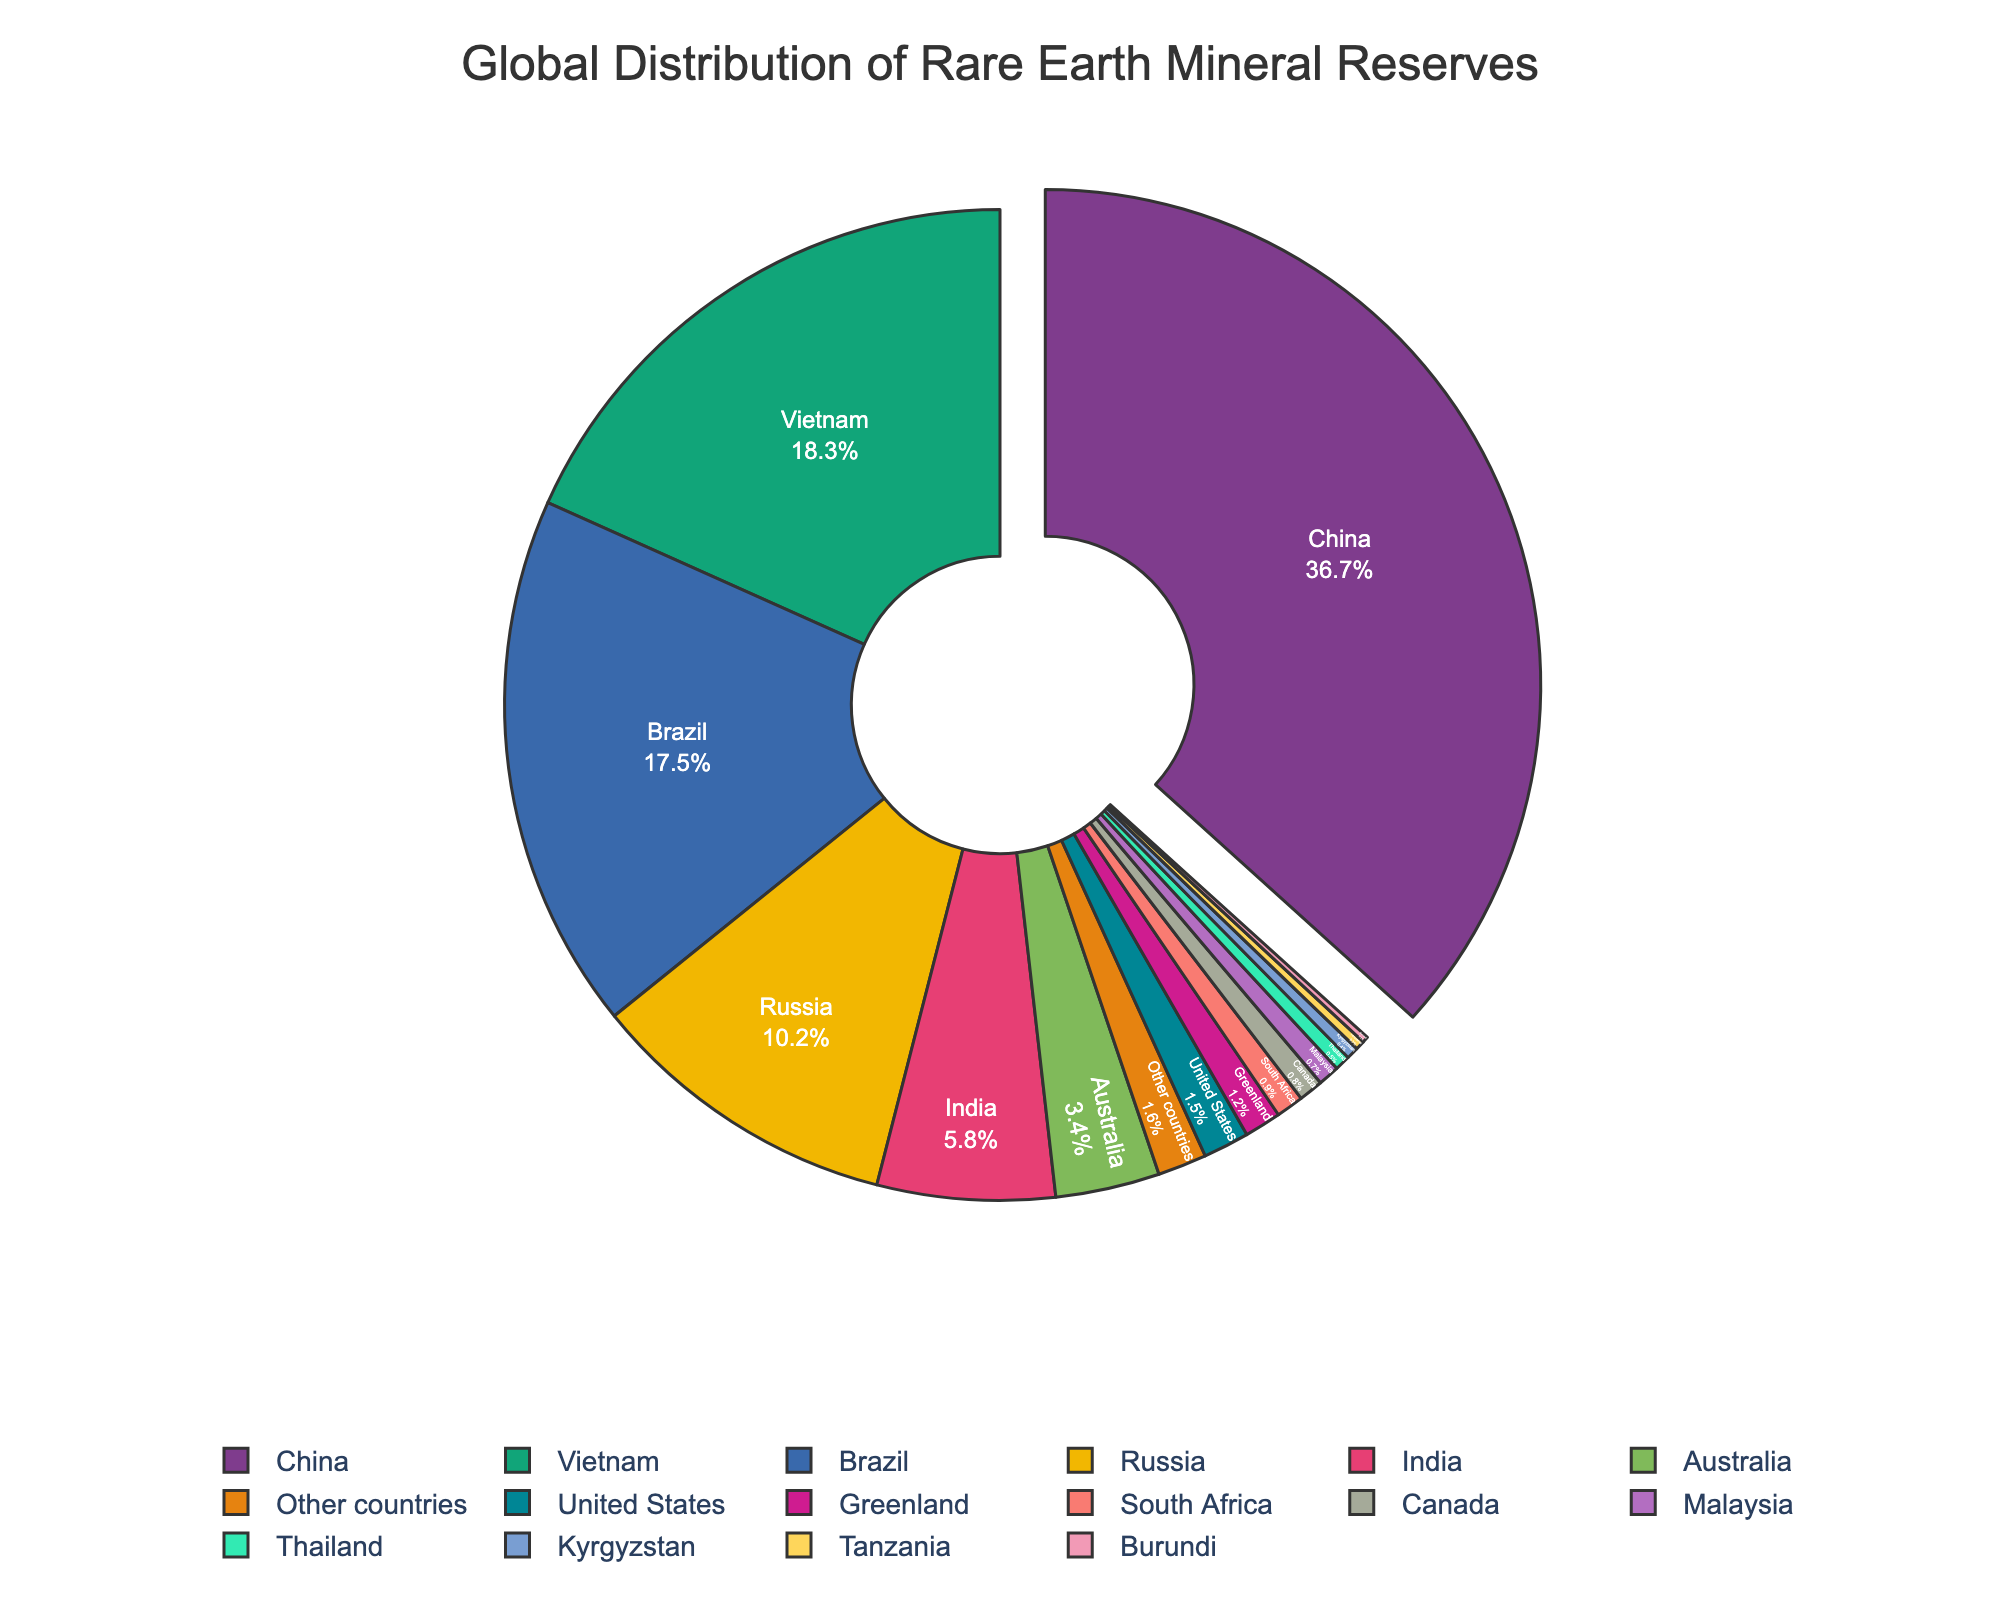What's the percentage contribution of China and Vietnam combined? China contributes 36.7% and Vietnam contributes 18.3%. Adding these together, 36.7 + 18.3 = 55.
Answer: 55% Which country has a higher percentage of reserves, Brazil or Russia? Brazil contributes 17.5% and Russia contributes 10.2%. Since 17.5 is greater than 10.2, Brazil has a higher percentage.
Answer: Brazil What is the combined percentage contribution of the United States, Greenland, and Canada? The United States contributes 1.5%, Greenland contributes 1.2%, and Canada contributes 0.8%. Adding these together, 1.5 + 1.2 + 0.8 = 3.5
Answer: 3.5% Excluding China, which country has the largest share of rare earth mineral reserves? Excluding China, the largest share is held by Vietnam, which has 18.3%.
Answer: Vietnam If we sum the contributions of India, Australia, and South Africa, how does it compare to Russia's contribution? India contributes 5.8%, Australia contributes 3.4%, and South Africa contributes 0.9%. Summing these, 5.8 + 3.4 + 0.9 = 10.1%, which is less than Russia's 10.2%.
Answer: Less than Russia What percentage of the global reserves is held by countries other than China, Vietnam, and Brazil? China holds 36.7%, Vietnam holds 18.3%, and Brazil holds 17.5%. Summing these gives 36.7 + 18.3 + 17.5 = 72.5%. The remaining percentage is 100 - 72.5 = 27.5%.
Answer: 27.5% Between India and Australia, which country has a lower percentage of reserves? India contributes 5.8% and Australia contributes 3.4%. Since 3.4 is less than 5.8, Australia has a lower percentage.
Answer: Australia Which three countries together encompass roughly a third of the global reserves? A third of the global reserves is approximately 33.3%. China contributes 36.7%, which alone is more than 33.3%. Excluding China, the next largest contributors are Vietnam (18.3%) and Brazil (17.5%), whose combined contribution, 18.3 + 17.5 = 35.8%, is also over a third. However, no precise combination of exactly three countries equals exactly 33.3%.
Answer: China (36.7%) What is the difference in the percentage of reserves between Australia and the United States? Australia contributes 3.4% and the United States contributes 1.5%. The difference between these two percentages is 3.4 - 1.5 = 1.9%.
Answer: 1.9% What is the visual characteristic of the country with the highest share in the pie chart? The country with the highest share is China, which has a segment pulled out slightly from the rest of the pie to highlight its significant contribution of 36.7%.
Answer: China's segment is pulled out 